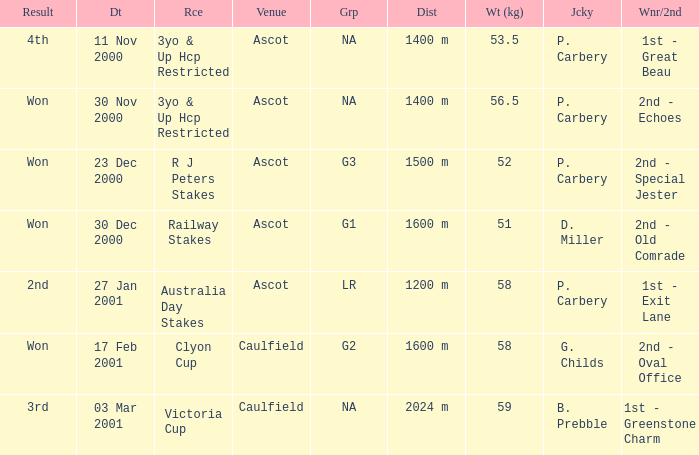What was the result for the railway stakes race? Won. 